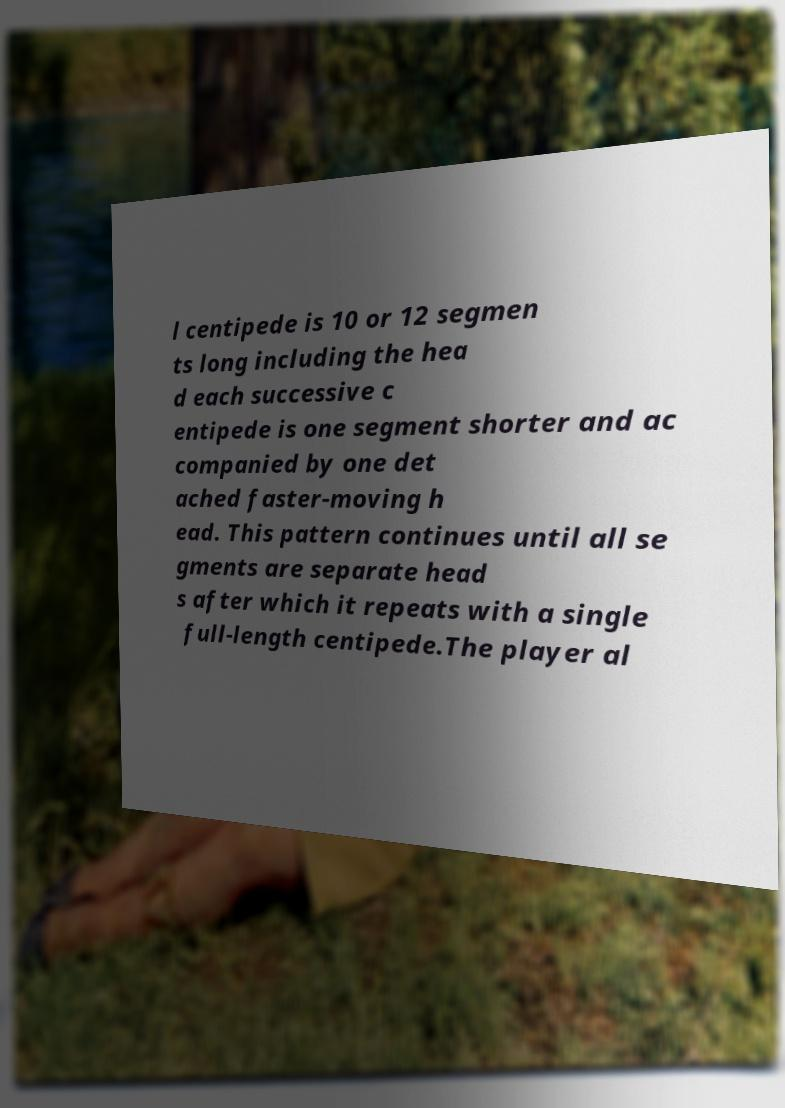For documentation purposes, I need the text within this image transcribed. Could you provide that? l centipede is 10 or 12 segmen ts long including the hea d each successive c entipede is one segment shorter and ac companied by one det ached faster-moving h ead. This pattern continues until all se gments are separate head s after which it repeats with a single full-length centipede.The player al 